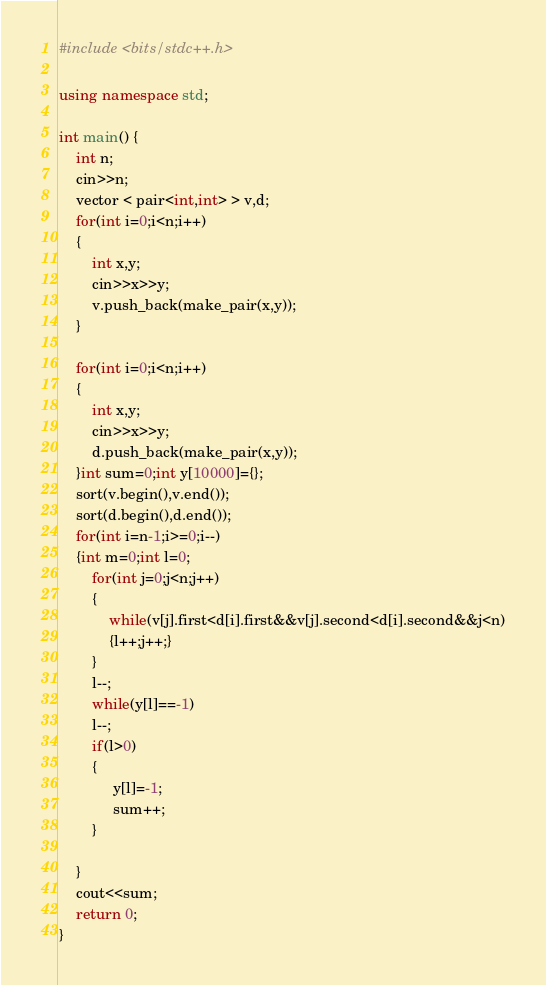Convert code to text. <code><loc_0><loc_0><loc_500><loc_500><_C++_>#include <bits/stdc++.h>

using namespace std;

int main() {
    int n;
    cin>>n;
    vector < pair<int,int> > v,d;
    for(int i=0;i<n;i++)
    {
        int x,y;
        cin>>x>>y;
        v.push_back(make_pair(x,y));
    }
    
    for(int i=0;i<n;i++)
    {
        int x,y;
        cin>>x>>y;
        d.push_back(make_pair(x,y));
    }int sum=0;int y[10000]={};
    sort(v.begin(),v.end());
    sort(d.begin(),d.end());
    for(int i=n-1;i>=0;i--)
    {int m=0;int l=0;
        for(int j=0;j<n;j++)
        {
            while(v[j].first<d[i].first&&v[j].second<d[i].second&&j<n)
            {l++;j++;}
        }
        l--;
        while(y[l]==-1)
        l--;
        if(l>0)
        {
             y[l]=-1;
             sum++;
        }
        
    }
    cout<<sum;
    return 0;
}</code> 